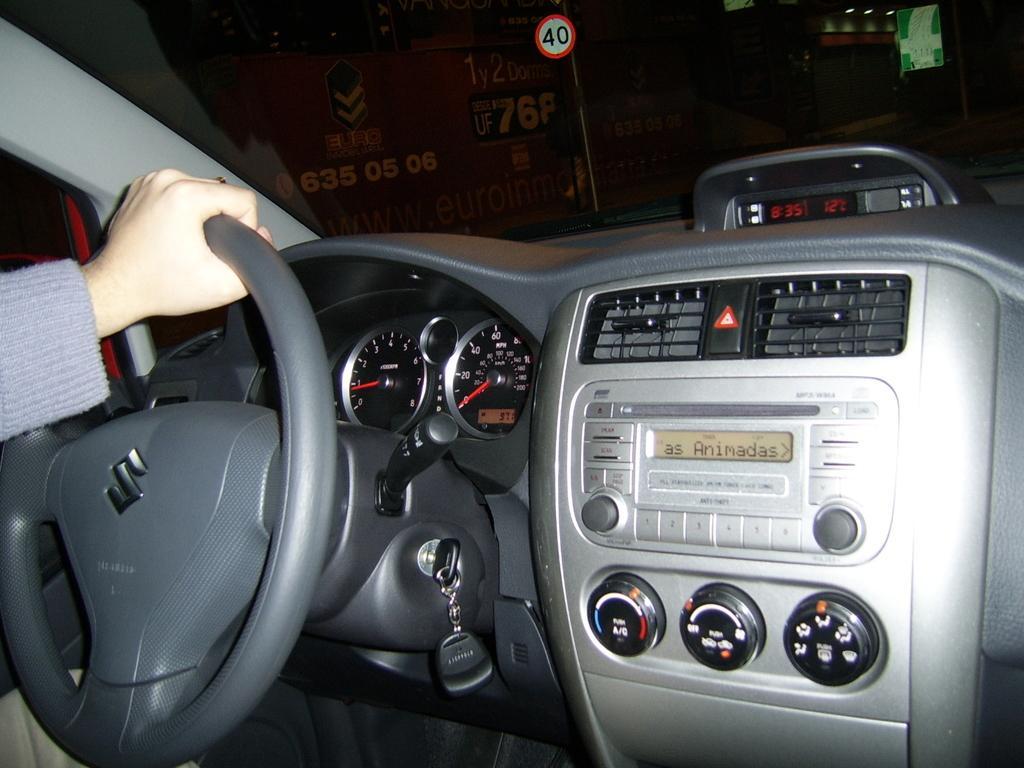Please provide a concise description of this image. In this image I can see the inner part of the vehicle. I can see the person holding the steering and the person is wearing the ash color dress. In the background I can see the lights and boards. 